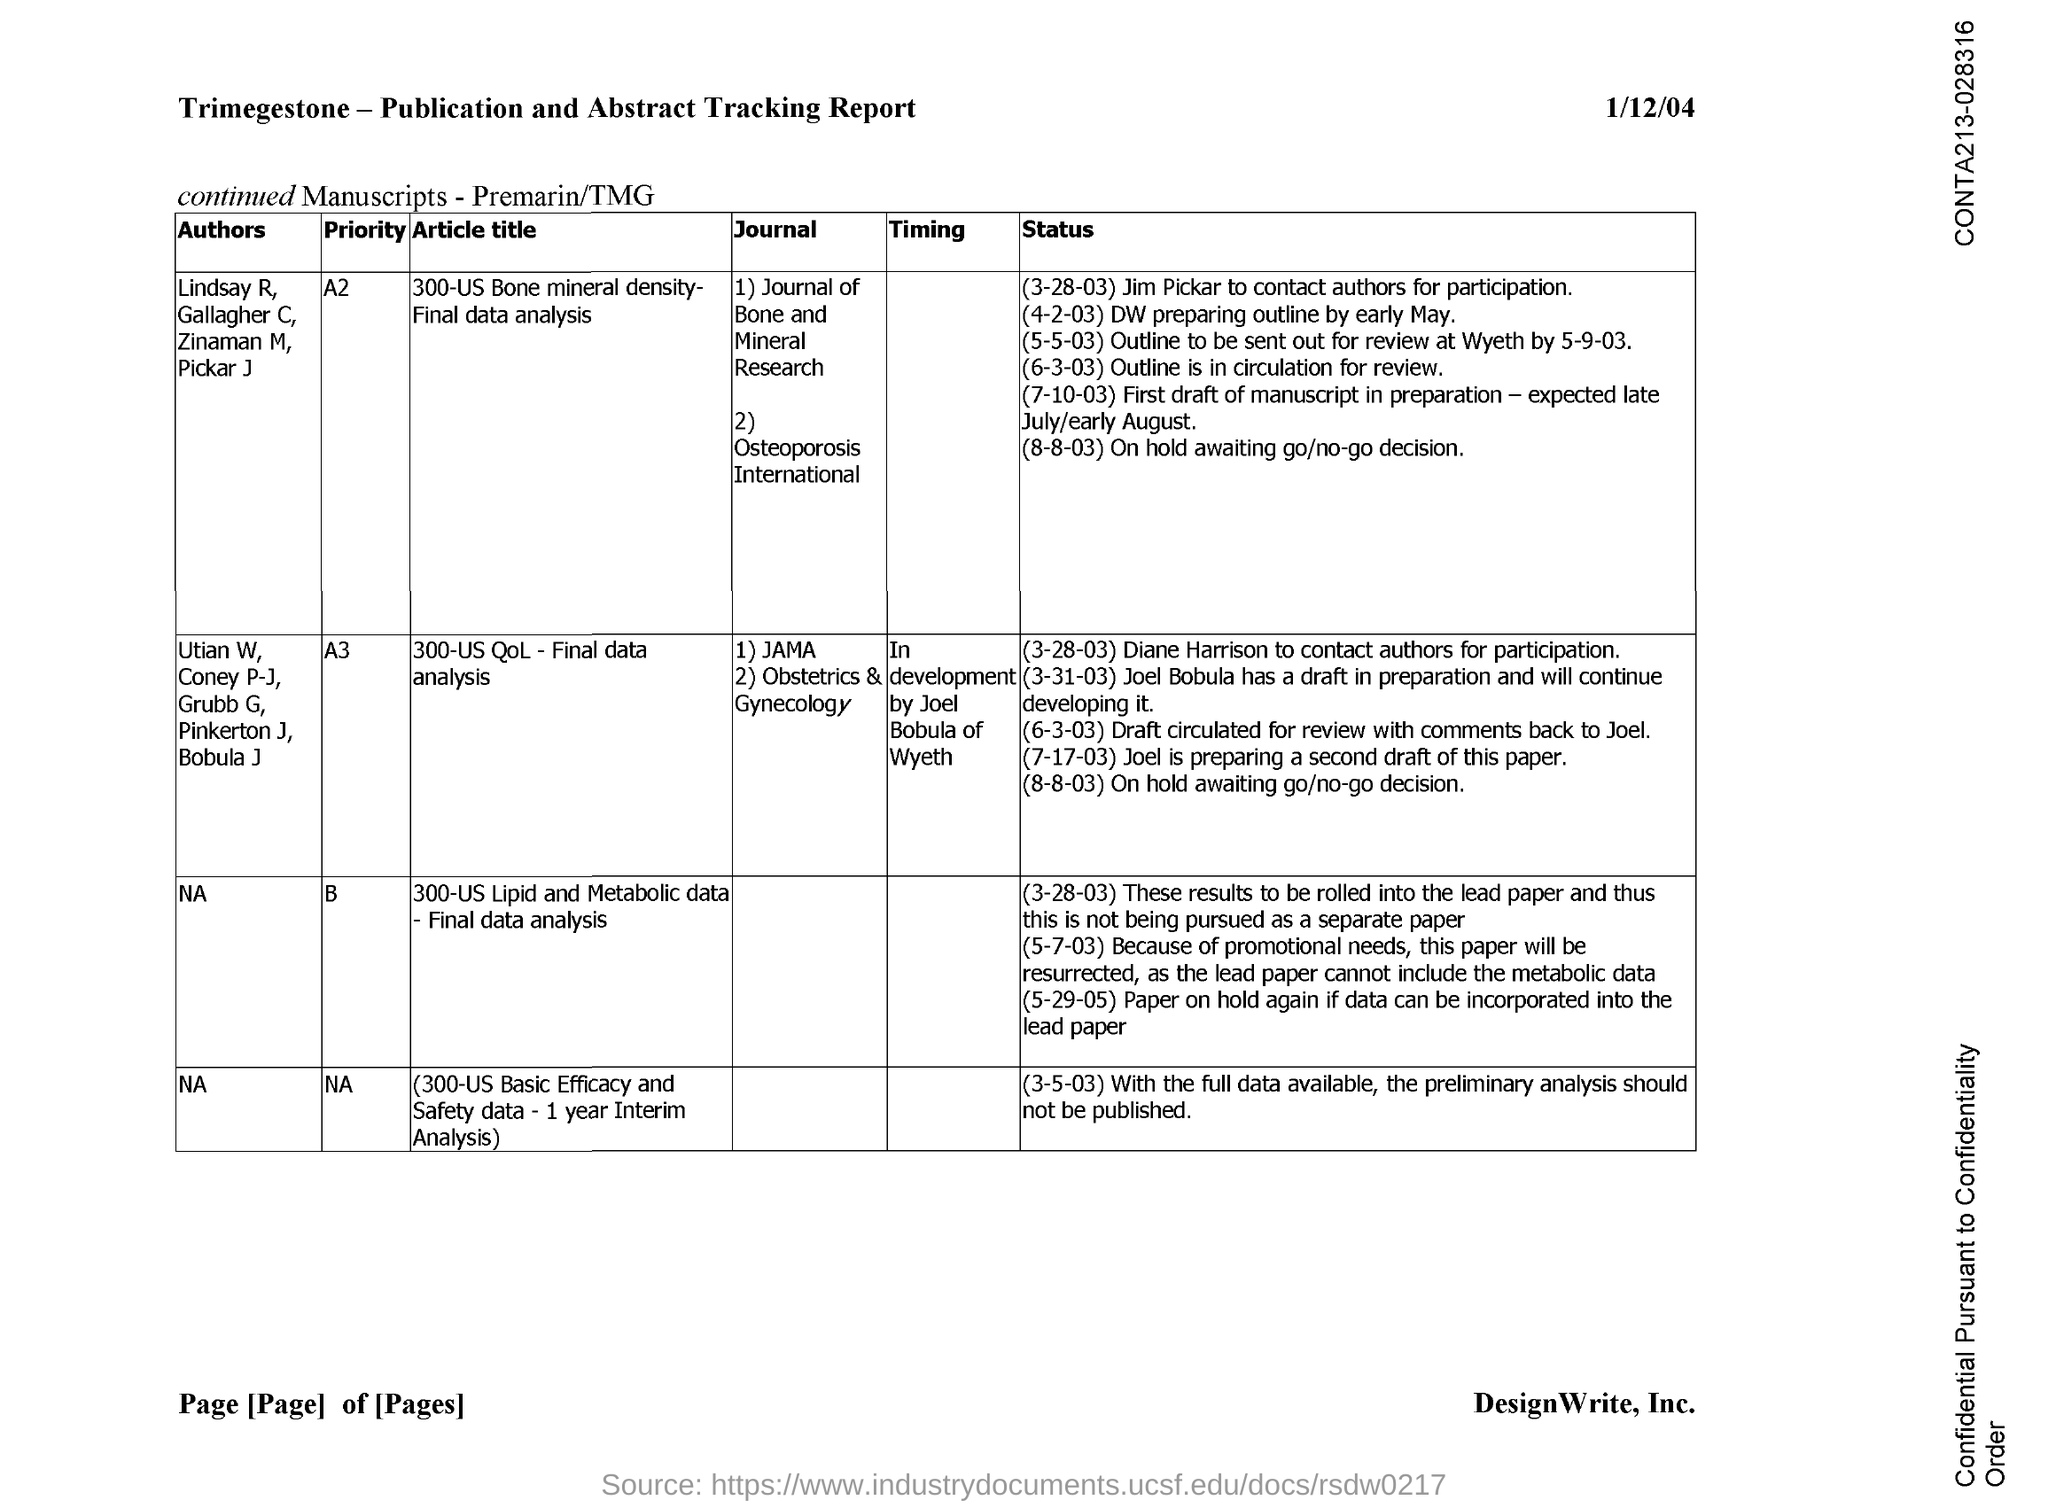Draw attention to some important aspects in this diagram. The document is titled "Trimegestone-Publication and Abstract Tracking Report. The article with priority A3 is titled '300-us QOL-Final Data Analysis.' 